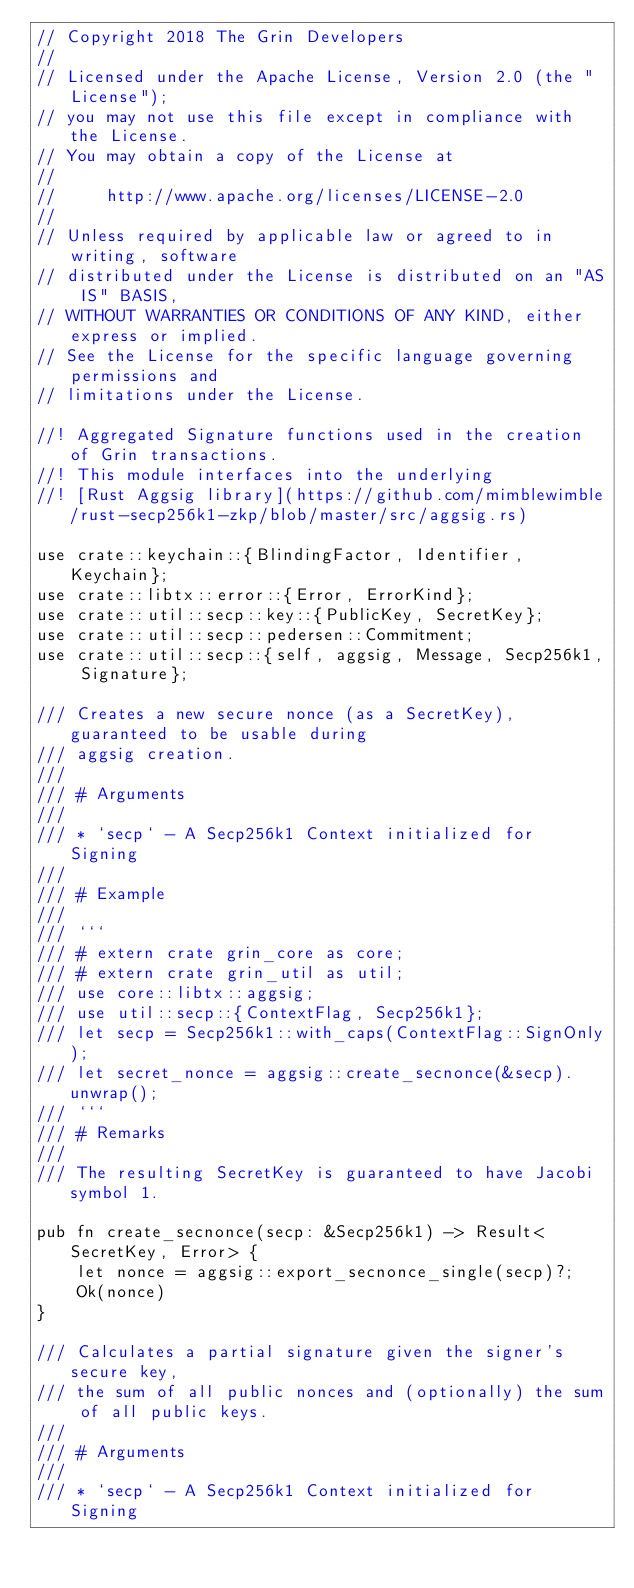Convert code to text. <code><loc_0><loc_0><loc_500><loc_500><_Rust_>// Copyright 2018 The Grin Developers
//
// Licensed under the Apache License, Version 2.0 (the "License");
// you may not use this file except in compliance with the License.
// You may obtain a copy of the License at
//
//     http://www.apache.org/licenses/LICENSE-2.0
//
// Unless required by applicable law or agreed to in writing, software
// distributed under the License is distributed on an "AS IS" BASIS,
// WITHOUT WARRANTIES OR CONDITIONS OF ANY KIND, either express or implied.
// See the License for the specific language governing permissions and
// limitations under the License.

//! Aggregated Signature functions used in the creation of Grin transactions.
//! This module interfaces into the underlying
//! [Rust Aggsig library](https://github.com/mimblewimble/rust-secp256k1-zkp/blob/master/src/aggsig.rs)

use crate::keychain::{BlindingFactor, Identifier, Keychain};
use crate::libtx::error::{Error, ErrorKind};
use crate::util::secp::key::{PublicKey, SecretKey};
use crate::util::secp::pedersen::Commitment;
use crate::util::secp::{self, aggsig, Message, Secp256k1, Signature};

/// Creates a new secure nonce (as a SecretKey), guaranteed to be usable during
/// aggsig creation.
///
/// # Arguments
///
/// * `secp` - A Secp256k1 Context initialized for Signing
///
/// # Example
///
/// ```
/// # extern crate grin_core as core;
/// # extern crate grin_util as util;
/// use core::libtx::aggsig;
/// use util::secp::{ContextFlag, Secp256k1};
/// let secp = Secp256k1::with_caps(ContextFlag::SignOnly);
/// let secret_nonce = aggsig::create_secnonce(&secp).unwrap();
/// ```
/// # Remarks
///
/// The resulting SecretKey is guaranteed to have Jacobi symbol 1.

pub fn create_secnonce(secp: &Secp256k1) -> Result<SecretKey, Error> {
	let nonce = aggsig::export_secnonce_single(secp)?;
	Ok(nonce)
}

/// Calculates a partial signature given the signer's secure key,
/// the sum of all public nonces and (optionally) the sum of all public keys.
///
/// # Arguments
///
/// * `secp` - A Secp256k1 Context initialized for Signing</code> 